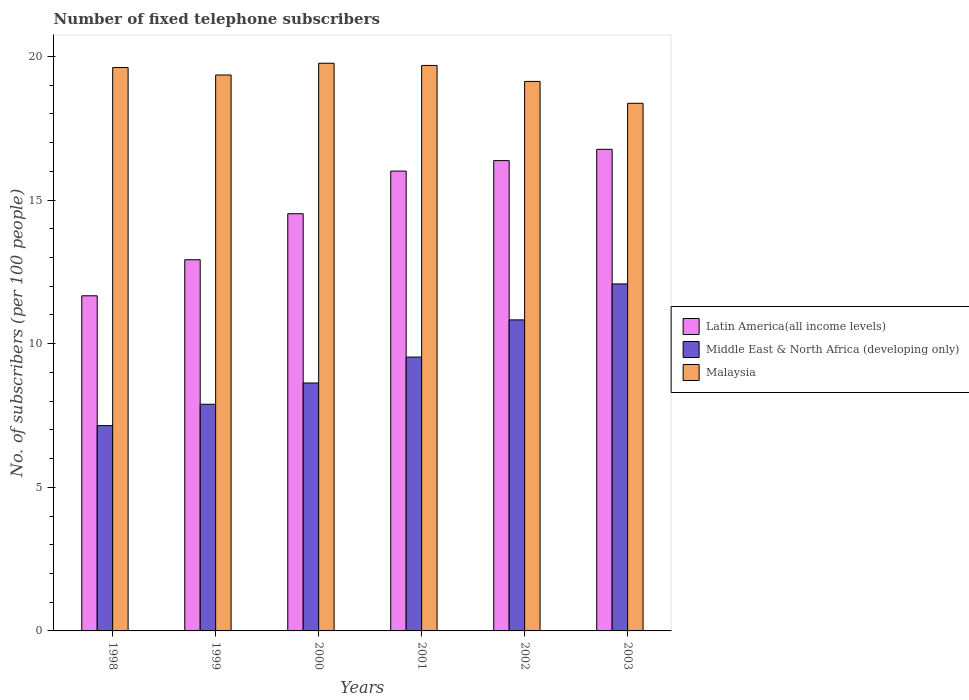How many different coloured bars are there?
Give a very brief answer. 3. How many groups of bars are there?
Your response must be concise. 6. What is the label of the 4th group of bars from the left?
Offer a very short reply. 2001. In how many cases, is the number of bars for a given year not equal to the number of legend labels?
Provide a succinct answer. 0. What is the number of fixed telephone subscribers in Malaysia in 1998?
Provide a short and direct response. 19.61. Across all years, what is the maximum number of fixed telephone subscribers in Latin America(all income levels)?
Ensure brevity in your answer.  16.76. Across all years, what is the minimum number of fixed telephone subscribers in Latin America(all income levels)?
Make the answer very short. 11.67. What is the total number of fixed telephone subscribers in Middle East & North Africa (developing only) in the graph?
Provide a short and direct response. 56.1. What is the difference between the number of fixed telephone subscribers in Malaysia in 2001 and that in 2002?
Offer a terse response. 0.56. What is the difference between the number of fixed telephone subscribers in Malaysia in 2000 and the number of fixed telephone subscribers in Latin America(all income levels) in 2002?
Provide a succinct answer. 3.39. What is the average number of fixed telephone subscribers in Latin America(all income levels) per year?
Your answer should be compact. 14.71. In the year 1998, what is the difference between the number of fixed telephone subscribers in Latin America(all income levels) and number of fixed telephone subscribers in Middle East & North Africa (developing only)?
Offer a terse response. 4.52. What is the ratio of the number of fixed telephone subscribers in Malaysia in 2002 to that in 2003?
Offer a terse response. 1.04. Is the number of fixed telephone subscribers in Malaysia in 1999 less than that in 2002?
Give a very brief answer. No. What is the difference between the highest and the second highest number of fixed telephone subscribers in Malaysia?
Offer a terse response. 0.08. What is the difference between the highest and the lowest number of fixed telephone subscribers in Latin America(all income levels)?
Give a very brief answer. 5.1. What does the 1st bar from the left in 2001 represents?
Make the answer very short. Latin America(all income levels). What does the 3rd bar from the right in 2000 represents?
Ensure brevity in your answer.  Latin America(all income levels). Is it the case that in every year, the sum of the number of fixed telephone subscribers in Latin America(all income levels) and number of fixed telephone subscribers in Middle East & North Africa (developing only) is greater than the number of fixed telephone subscribers in Malaysia?
Give a very brief answer. No. Are all the bars in the graph horizontal?
Give a very brief answer. No. How many years are there in the graph?
Your response must be concise. 6. Does the graph contain any zero values?
Offer a very short reply. No. Does the graph contain grids?
Give a very brief answer. No. Where does the legend appear in the graph?
Your answer should be very brief. Center right. How many legend labels are there?
Your response must be concise. 3. How are the legend labels stacked?
Your response must be concise. Vertical. What is the title of the graph?
Offer a very short reply. Number of fixed telephone subscribers. Does "Virgin Islands" appear as one of the legend labels in the graph?
Your answer should be very brief. No. What is the label or title of the Y-axis?
Provide a succinct answer. No. of subscribers (per 100 people). What is the No. of subscribers (per 100 people) of Latin America(all income levels) in 1998?
Provide a succinct answer. 11.67. What is the No. of subscribers (per 100 people) in Middle East & North Africa (developing only) in 1998?
Give a very brief answer. 7.15. What is the No. of subscribers (per 100 people) in Malaysia in 1998?
Keep it short and to the point. 19.61. What is the No. of subscribers (per 100 people) of Latin America(all income levels) in 1999?
Provide a short and direct response. 12.92. What is the No. of subscribers (per 100 people) in Middle East & North Africa (developing only) in 1999?
Give a very brief answer. 7.89. What is the No. of subscribers (per 100 people) of Malaysia in 1999?
Your response must be concise. 19.35. What is the No. of subscribers (per 100 people) in Latin America(all income levels) in 2000?
Your answer should be compact. 14.52. What is the No. of subscribers (per 100 people) in Middle East & North Africa (developing only) in 2000?
Provide a short and direct response. 8.63. What is the No. of subscribers (per 100 people) in Malaysia in 2000?
Your answer should be very brief. 19.76. What is the No. of subscribers (per 100 people) in Latin America(all income levels) in 2001?
Give a very brief answer. 16.01. What is the No. of subscribers (per 100 people) of Middle East & North Africa (developing only) in 2001?
Your answer should be compact. 9.53. What is the No. of subscribers (per 100 people) in Malaysia in 2001?
Make the answer very short. 19.68. What is the No. of subscribers (per 100 people) of Latin America(all income levels) in 2002?
Offer a terse response. 16.37. What is the No. of subscribers (per 100 people) of Middle East & North Africa (developing only) in 2002?
Keep it short and to the point. 10.83. What is the No. of subscribers (per 100 people) of Malaysia in 2002?
Offer a very short reply. 19.13. What is the No. of subscribers (per 100 people) in Latin America(all income levels) in 2003?
Give a very brief answer. 16.76. What is the No. of subscribers (per 100 people) of Middle East & North Africa (developing only) in 2003?
Offer a terse response. 12.08. What is the No. of subscribers (per 100 people) of Malaysia in 2003?
Offer a very short reply. 18.37. Across all years, what is the maximum No. of subscribers (per 100 people) in Latin America(all income levels)?
Give a very brief answer. 16.76. Across all years, what is the maximum No. of subscribers (per 100 people) of Middle East & North Africa (developing only)?
Offer a very short reply. 12.08. Across all years, what is the maximum No. of subscribers (per 100 people) of Malaysia?
Provide a succinct answer. 19.76. Across all years, what is the minimum No. of subscribers (per 100 people) of Latin America(all income levels)?
Offer a terse response. 11.67. Across all years, what is the minimum No. of subscribers (per 100 people) of Middle East & North Africa (developing only)?
Your response must be concise. 7.15. Across all years, what is the minimum No. of subscribers (per 100 people) in Malaysia?
Your answer should be very brief. 18.37. What is the total No. of subscribers (per 100 people) in Latin America(all income levels) in the graph?
Your response must be concise. 88.25. What is the total No. of subscribers (per 100 people) in Middle East & North Africa (developing only) in the graph?
Make the answer very short. 56.1. What is the total No. of subscribers (per 100 people) of Malaysia in the graph?
Offer a terse response. 115.9. What is the difference between the No. of subscribers (per 100 people) of Latin America(all income levels) in 1998 and that in 1999?
Offer a terse response. -1.25. What is the difference between the No. of subscribers (per 100 people) in Middle East & North Africa (developing only) in 1998 and that in 1999?
Provide a succinct answer. -0.74. What is the difference between the No. of subscribers (per 100 people) in Malaysia in 1998 and that in 1999?
Provide a succinct answer. 0.26. What is the difference between the No. of subscribers (per 100 people) of Latin America(all income levels) in 1998 and that in 2000?
Your answer should be very brief. -2.86. What is the difference between the No. of subscribers (per 100 people) of Middle East & North Africa (developing only) in 1998 and that in 2000?
Offer a terse response. -1.48. What is the difference between the No. of subscribers (per 100 people) in Malaysia in 1998 and that in 2000?
Offer a very short reply. -0.15. What is the difference between the No. of subscribers (per 100 people) in Latin America(all income levels) in 1998 and that in 2001?
Provide a short and direct response. -4.34. What is the difference between the No. of subscribers (per 100 people) of Middle East & North Africa (developing only) in 1998 and that in 2001?
Make the answer very short. -2.39. What is the difference between the No. of subscribers (per 100 people) in Malaysia in 1998 and that in 2001?
Give a very brief answer. -0.07. What is the difference between the No. of subscribers (per 100 people) in Latin America(all income levels) in 1998 and that in 2002?
Keep it short and to the point. -4.71. What is the difference between the No. of subscribers (per 100 people) in Middle East & North Africa (developing only) in 1998 and that in 2002?
Your answer should be compact. -3.68. What is the difference between the No. of subscribers (per 100 people) in Malaysia in 1998 and that in 2002?
Ensure brevity in your answer.  0.48. What is the difference between the No. of subscribers (per 100 people) of Latin America(all income levels) in 1998 and that in 2003?
Offer a terse response. -5.1. What is the difference between the No. of subscribers (per 100 people) in Middle East & North Africa (developing only) in 1998 and that in 2003?
Offer a terse response. -4.93. What is the difference between the No. of subscribers (per 100 people) of Malaysia in 1998 and that in 2003?
Make the answer very short. 1.24. What is the difference between the No. of subscribers (per 100 people) of Latin America(all income levels) in 1999 and that in 2000?
Offer a very short reply. -1.6. What is the difference between the No. of subscribers (per 100 people) of Middle East & North Africa (developing only) in 1999 and that in 2000?
Provide a succinct answer. -0.74. What is the difference between the No. of subscribers (per 100 people) of Malaysia in 1999 and that in 2000?
Give a very brief answer. -0.41. What is the difference between the No. of subscribers (per 100 people) of Latin America(all income levels) in 1999 and that in 2001?
Offer a very short reply. -3.09. What is the difference between the No. of subscribers (per 100 people) in Middle East & North Africa (developing only) in 1999 and that in 2001?
Provide a succinct answer. -1.64. What is the difference between the No. of subscribers (per 100 people) of Malaysia in 1999 and that in 2001?
Your answer should be very brief. -0.33. What is the difference between the No. of subscribers (per 100 people) of Latin America(all income levels) in 1999 and that in 2002?
Give a very brief answer. -3.45. What is the difference between the No. of subscribers (per 100 people) of Middle East & North Africa (developing only) in 1999 and that in 2002?
Your response must be concise. -2.94. What is the difference between the No. of subscribers (per 100 people) in Malaysia in 1999 and that in 2002?
Your response must be concise. 0.22. What is the difference between the No. of subscribers (per 100 people) in Latin America(all income levels) in 1999 and that in 2003?
Provide a short and direct response. -3.84. What is the difference between the No. of subscribers (per 100 people) of Middle East & North Africa (developing only) in 1999 and that in 2003?
Your answer should be compact. -4.19. What is the difference between the No. of subscribers (per 100 people) of Malaysia in 1999 and that in 2003?
Make the answer very short. 0.99. What is the difference between the No. of subscribers (per 100 people) of Latin America(all income levels) in 2000 and that in 2001?
Keep it short and to the point. -1.48. What is the difference between the No. of subscribers (per 100 people) of Middle East & North Africa (developing only) in 2000 and that in 2001?
Provide a succinct answer. -0.9. What is the difference between the No. of subscribers (per 100 people) in Malaysia in 2000 and that in 2001?
Offer a very short reply. 0.08. What is the difference between the No. of subscribers (per 100 people) of Latin America(all income levels) in 2000 and that in 2002?
Provide a succinct answer. -1.85. What is the difference between the No. of subscribers (per 100 people) in Middle East & North Africa (developing only) in 2000 and that in 2002?
Provide a short and direct response. -2.2. What is the difference between the No. of subscribers (per 100 people) in Malaysia in 2000 and that in 2002?
Your response must be concise. 0.63. What is the difference between the No. of subscribers (per 100 people) in Latin America(all income levels) in 2000 and that in 2003?
Give a very brief answer. -2.24. What is the difference between the No. of subscribers (per 100 people) in Middle East & North Africa (developing only) in 2000 and that in 2003?
Make the answer very short. -3.45. What is the difference between the No. of subscribers (per 100 people) in Malaysia in 2000 and that in 2003?
Provide a short and direct response. 1.39. What is the difference between the No. of subscribers (per 100 people) of Latin America(all income levels) in 2001 and that in 2002?
Keep it short and to the point. -0.37. What is the difference between the No. of subscribers (per 100 people) of Middle East & North Africa (developing only) in 2001 and that in 2002?
Offer a terse response. -1.29. What is the difference between the No. of subscribers (per 100 people) of Malaysia in 2001 and that in 2002?
Your response must be concise. 0.56. What is the difference between the No. of subscribers (per 100 people) of Latin America(all income levels) in 2001 and that in 2003?
Give a very brief answer. -0.76. What is the difference between the No. of subscribers (per 100 people) of Middle East & North Africa (developing only) in 2001 and that in 2003?
Your answer should be very brief. -2.55. What is the difference between the No. of subscribers (per 100 people) in Malaysia in 2001 and that in 2003?
Your response must be concise. 1.32. What is the difference between the No. of subscribers (per 100 people) in Latin America(all income levels) in 2002 and that in 2003?
Ensure brevity in your answer.  -0.39. What is the difference between the No. of subscribers (per 100 people) of Middle East & North Africa (developing only) in 2002 and that in 2003?
Your answer should be very brief. -1.25. What is the difference between the No. of subscribers (per 100 people) in Malaysia in 2002 and that in 2003?
Offer a terse response. 0.76. What is the difference between the No. of subscribers (per 100 people) of Latin America(all income levels) in 1998 and the No. of subscribers (per 100 people) of Middle East & North Africa (developing only) in 1999?
Keep it short and to the point. 3.78. What is the difference between the No. of subscribers (per 100 people) in Latin America(all income levels) in 1998 and the No. of subscribers (per 100 people) in Malaysia in 1999?
Make the answer very short. -7.69. What is the difference between the No. of subscribers (per 100 people) of Middle East & North Africa (developing only) in 1998 and the No. of subscribers (per 100 people) of Malaysia in 1999?
Your response must be concise. -12.21. What is the difference between the No. of subscribers (per 100 people) in Latin America(all income levels) in 1998 and the No. of subscribers (per 100 people) in Middle East & North Africa (developing only) in 2000?
Provide a succinct answer. 3.04. What is the difference between the No. of subscribers (per 100 people) in Latin America(all income levels) in 1998 and the No. of subscribers (per 100 people) in Malaysia in 2000?
Offer a very short reply. -8.09. What is the difference between the No. of subscribers (per 100 people) in Middle East & North Africa (developing only) in 1998 and the No. of subscribers (per 100 people) in Malaysia in 2000?
Your answer should be very brief. -12.61. What is the difference between the No. of subscribers (per 100 people) of Latin America(all income levels) in 1998 and the No. of subscribers (per 100 people) of Middle East & North Africa (developing only) in 2001?
Offer a very short reply. 2.13. What is the difference between the No. of subscribers (per 100 people) of Latin America(all income levels) in 1998 and the No. of subscribers (per 100 people) of Malaysia in 2001?
Provide a short and direct response. -8.02. What is the difference between the No. of subscribers (per 100 people) of Middle East & North Africa (developing only) in 1998 and the No. of subscribers (per 100 people) of Malaysia in 2001?
Make the answer very short. -12.54. What is the difference between the No. of subscribers (per 100 people) of Latin America(all income levels) in 1998 and the No. of subscribers (per 100 people) of Middle East & North Africa (developing only) in 2002?
Give a very brief answer. 0.84. What is the difference between the No. of subscribers (per 100 people) of Latin America(all income levels) in 1998 and the No. of subscribers (per 100 people) of Malaysia in 2002?
Make the answer very short. -7.46. What is the difference between the No. of subscribers (per 100 people) in Middle East & North Africa (developing only) in 1998 and the No. of subscribers (per 100 people) in Malaysia in 2002?
Provide a short and direct response. -11.98. What is the difference between the No. of subscribers (per 100 people) in Latin America(all income levels) in 1998 and the No. of subscribers (per 100 people) in Middle East & North Africa (developing only) in 2003?
Ensure brevity in your answer.  -0.41. What is the difference between the No. of subscribers (per 100 people) of Latin America(all income levels) in 1998 and the No. of subscribers (per 100 people) of Malaysia in 2003?
Keep it short and to the point. -6.7. What is the difference between the No. of subscribers (per 100 people) in Middle East & North Africa (developing only) in 1998 and the No. of subscribers (per 100 people) in Malaysia in 2003?
Offer a terse response. -11.22. What is the difference between the No. of subscribers (per 100 people) in Latin America(all income levels) in 1999 and the No. of subscribers (per 100 people) in Middle East & North Africa (developing only) in 2000?
Ensure brevity in your answer.  4.29. What is the difference between the No. of subscribers (per 100 people) in Latin America(all income levels) in 1999 and the No. of subscribers (per 100 people) in Malaysia in 2000?
Offer a very short reply. -6.84. What is the difference between the No. of subscribers (per 100 people) of Middle East & North Africa (developing only) in 1999 and the No. of subscribers (per 100 people) of Malaysia in 2000?
Offer a terse response. -11.87. What is the difference between the No. of subscribers (per 100 people) in Latin America(all income levels) in 1999 and the No. of subscribers (per 100 people) in Middle East & North Africa (developing only) in 2001?
Your answer should be very brief. 3.39. What is the difference between the No. of subscribers (per 100 people) in Latin America(all income levels) in 1999 and the No. of subscribers (per 100 people) in Malaysia in 2001?
Give a very brief answer. -6.76. What is the difference between the No. of subscribers (per 100 people) of Middle East & North Africa (developing only) in 1999 and the No. of subscribers (per 100 people) of Malaysia in 2001?
Make the answer very short. -11.79. What is the difference between the No. of subscribers (per 100 people) in Latin America(all income levels) in 1999 and the No. of subscribers (per 100 people) in Middle East & North Africa (developing only) in 2002?
Your answer should be compact. 2.09. What is the difference between the No. of subscribers (per 100 people) of Latin America(all income levels) in 1999 and the No. of subscribers (per 100 people) of Malaysia in 2002?
Keep it short and to the point. -6.21. What is the difference between the No. of subscribers (per 100 people) of Middle East & North Africa (developing only) in 1999 and the No. of subscribers (per 100 people) of Malaysia in 2002?
Provide a succinct answer. -11.24. What is the difference between the No. of subscribers (per 100 people) in Latin America(all income levels) in 1999 and the No. of subscribers (per 100 people) in Middle East & North Africa (developing only) in 2003?
Give a very brief answer. 0.84. What is the difference between the No. of subscribers (per 100 people) of Latin America(all income levels) in 1999 and the No. of subscribers (per 100 people) of Malaysia in 2003?
Make the answer very short. -5.45. What is the difference between the No. of subscribers (per 100 people) of Middle East & North Africa (developing only) in 1999 and the No. of subscribers (per 100 people) of Malaysia in 2003?
Provide a succinct answer. -10.48. What is the difference between the No. of subscribers (per 100 people) of Latin America(all income levels) in 2000 and the No. of subscribers (per 100 people) of Middle East & North Africa (developing only) in 2001?
Keep it short and to the point. 4.99. What is the difference between the No. of subscribers (per 100 people) in Latin America(all income levels) in 2000 and the No. of subscribers (per 100 people) in Malaysia in 2001?
Offer a terse response. -5.16. What is the difference between the No. of subscribers (per 100 people) of Middle East & North Africa (developing only) in 2000 and the No. of subscribers (per 100 people) of Malaysia in 2001?
Offer a terse response. -11.05. What is the difference between the No. of subscribers (per 100 people) of Latin America(all income levels) in 2000 and the No. of subscribers (per 100 people) of Middle East & North Africa (developing only) in 2002?
Keep it short and to the point. 3.7. What is the difference between the No. of subscribers (per 100 people) of Latin America(all income levels) in 2000 and the No. of subscribers (per 100 people) of Malaysia in 2002?
Ensure brevity in your answer.  -4.61. What is the difference between the No. of subscribers (per 100 people) of Middle East & North Africa (developing only) in 2000 and the No. of subscribers (per 100 people) of Malaysia in 2002?
Offer a terse response. -10.5. What is the difference between the No. of subscribers (per 100 people) of Latin America(all income levels) in 2000 and the No. of subscribers (per 100 people) of Middle East & North Africa (developing only) in 2003?
Your answer should be compact. 2.44. What is the difference between the No. of subscribers (per 100 people) in Latin America(all income levels) in 2000 and the No. of subscribers (per 100 people) in Malaysia in 2003?
Give a very brief answer. -3.84. What is the difference between the No. of subscribers (per 100 people) of Middle East & North Africa (developing only) in 2000 and the No. of subscribers (per 100 people) of Malaysia in 2003?
Give a very brief answer. -9.74. What is the difference between the No. of subscribers (per 100 people) in Latin America(all income levels) in 2001 and the No. of subscribers (per 100 people) in Middle East & North Africa (developing only) in 2002?
Provide a short and direct response. 5.18. What is the difference between the No. of subscribers (per 100 people) in Latin America(all income levels) in 2001 and the No. of subscribers (per 100 people) in Malaysia in 2002?
Provide a succinct answer. -3.12. What is the difference between the No. of subscribers (per 100 people) in Middle East & North Africa (developing only) in 2001 and the No. of subscribers (per 100 people) in Malaysia in 2002?
Your answer should be compact. -9.6. What is the difference between the No. of subscribers (per 100 people) of Latin America(all income levels) in 2001 and the No. of subscribers (per 100 people) of Middle East & North Africa (developing only) in 2003?
Give a very brief answer. 3.93. What is the difference between the No. of subscribers (per 100 people) in Latin America(all income levels) in 2001 and the No. of subscribers (per 100 people) in Malaysia in 2003?
Your response must be concise. -2.36. What is the difference between the No. of subscribers (per 100 people) of Middle East & North Africa (developing only) in 2001 and the No. of subscribers (per 100 people) of Malaysia in 2003?
Provide a succinct answer. -8.83. What is the difference between the No. of subscribers (per 100 people) of Latin America(all income levels) in 2002 and the No. of subscribers (per 100 people) of Middle East & North Africa (developing only) in 2003?
Offer a terse response. 4.29. What is the difference between the No. of subscribers (per 100 people) of Latin America(all income levels) in 2002 and the No. of subscribers (per 100 people) of Malaysia in 2003?
Provide a short and direct response. -1.99. What is the difference between the No. of subscribers (per 100 people) in Middle East & North Africa (developing only) in 2002 and the No. of subscribers (per 100 people) in Malaysia in 2003?
Give a very brief answer. -7.54. What is the average No. of subscribers (per 100 people) in Latin America(all income levels) per year?
Make the answer very short. 14.71. What is the average No. of subscribers (per 100 people) in Middle East & North Africa (developing only) per year?
Your answer should be very brief. 9.35. What is the average No. of subscribers (per 100 people) of Malaysia per year?
Offer a very short reply. 19.32. In the year 1998, what is the difference between the No. of subscribers (per 100 people) in Latin America(all income levels) and No. of subscribers (per 100 people) in Middle East & North Africa (developing only)?
Your answer should be compact. 4.52. In the year 1998, what is the difference between the No. of subscribers (per 100 people) in Latin America(all income levels) and No. of subscribers (per 100 people) in Malaysia?
Give a very brief answer. -7.95. In the year 1998, what is the difference between the No. of subscribers (per 100 people) of Middle East & North Africa (developing only) and No. of subscribers (per 100 people) of Malaysia?
Give a very brief answer. -12.47. In the year 1999, what is the difference between the No. of subscribers (per 100 people) in Latin America(all income levels) and No. of subscribers (per 100 people) in Middle East & North Africa (developing only)?
Make the answer very short. 5.03. In the year 1999, what is the difference between the No. of subscribers (per 100 people) of Latin America(all income levels) and No. of subscribers (per 100 people) of Malaysia?
Your answer should be compact. -6.43. In the year 1999, what is the difference between the No. of subscribers (per 100 people) in Middle East & North Africa (developing only) and No. of subscribers (per 100 people) in Malaysia?
Your answer should be compact. -11.46. In the year 2000, what is the difference between the No. of subscribers (per 100 people) in Latin America(all income levels) and No. of subscribers (per 100 people) in Middle East & North Africa (developing only)?
Give a very brief answer. 5.89. In the year 2000, what is the difference between the No. of subscribers (per 100 people) of Latin America(all income levels) and No. of subscribers (per 100 people) of Malaysia?
Provide a short and direct response. -5.24. In the year 2000, what is the difference between the No. of subscribers (per 100 people) of Middle East & North Africa (developing only) and No. of subscribers (per 100 people) of Malaysia?
Give a very brief answer. -11.13. In the year 2001, what is the difference between the No. of subscribers (per 100 people) in Latin America(all income levels) and No. of subscribers (per 100 people) in Middle East & North Africa (developing only)?
Offer a very short reply. 6.47. In the year 2001, what is the difference between the No. of subscribers (per 100 people) in Latin America(all income levels) and No. of subscribers (per 100 people) in Malaysia?
Keep it short and to the point. -3.68. In the year 2001, what is the difference between the No. of subscribers (per 100 people) in Middle East & North Africa (developing only) and No. of subscribers (per 100 people) in Malaysia?
Offer a terse response. -10.15. In the year 2002, what is the difference between the No. of subscribers (per 100 people) of Latin America(all income levels) and No. of subscribers (per 100 people) of Middle East & North Africa (developing only)?
Your response must be concise. 5.54. In the year 2002, what is the difference between the No. of subscribers (per 100 people) in Latin America(all income levels) and No. of subscribers (per 100 people) in Malaysia?
Provide a short and direct response. -2.76. In the year 2002, what is the difference between the No. of subscribers (per 100 people) of Middle East & North Africa (developing only) and No. of subscribers (per 100 people) of Malaysia?
Provide a short and direct response. -8.3. In the year 2003, what is the difference between the No. of subscribers (per 100 people) of Latin America(all income levels) and No. of subscribers (per 100 people) of Middle East & North Africa (developing only)?
Offer a terse response. 4.69. In the year 2003, what is the difference between the No. of subscribers (per 100 people) of Latin America(all income levels) and No. of subscribers (per 100 people) of Malaysia?
Ensure brevity in your answer.  -1.6. In the year 2003, what is the difference between the No. of subscribers (per 100 people) in Middle East & North Africa (developing only) and No. of subscribers (per 100 people) in Malaysia?
Offer a terse response. -6.29. What is the ratio of the No. of subscribers (per 100 people) of Latin America(all income levels) in 1998 to that in 1999?
Ensure brevity in your answer.  0.9. What is the ratio of the No. of subscribers (per 100 people) in Middle East & North Africa (developing only) in 1998 to that in 1999?
Provide a short and direct response. 0.91. What is the ratio of the No. of subscribers (per 100 people) in Malaysia in 1998 to that in 1999?
Make the answer very short. 1.01. What is the ratio of the No. of subscribers (per 100 people) of Latin America(all income levels) in 1998 to that in 2000?
Keep it short and to the point. 0.8. What is the ratio of the No. of subscribers (per 100 people) of Middle East & North Africa (developing only) in 1998 to that in 2000?
Offer a terse response. 0.83. What is the ratio of the No. of subscribers (per 100 people) in Latin America(all income levels) in 1998 to that in 2001?
Offer a terse response. 0.73. What is the ratio of the No. of subscribers (per 100 people) of Middle East & North Africa (developing only) in 1998 to that in 2001?
Give a very brief answer. 0.75. What is the ratio of the No. of subscribers (per 100 people) in Malaysia in 1998 to that in 2001?
Make the answer very short. 1. What is the ratio of the No. of subscribers (per 100 people) in Latin America(all income levels) in 1998 to that in 2002?
Your answer should be compact. 0.71. What is the ratio of the No. of subscribers (per 100 people) in Middle East & North Africa (developing only) in 1998 to that in 2002?
Your answer should be very brief. 0.66. What is the ratio of the No. of subscribers (per 100 people) of Malaysia in 1998 to that in 2002?
Offer a very short reply. 1.03. What is the ratio of the No. of subscribers (per 100 people) of Latin America(all income levels) in 1998 to that in 2003?
Provide a short and direct response. 0.7. What is the ratio of the No. of subscribers (per 100 people) in Middle East & North Africa (developing only) in 1998 to that in 2003?
Keep it short and to the point. 0.59. What is the ratio of the No. of subscribers (per 100 people) in Malaysia in 1998 to that in 2003?
Your answer should be compact. 1.07. What is the ratio of the No. of subscribers (per 100 people) of Latin America(all income levels) in 1999 to that in 2000?
Make the answer very short. 0.89. What is the ratio of the No. of subscribers (per 100 people) of Middle East & North Africa (developing only) in 1999 to that in 2000?
Offer a terse response. 0.91. What is the ratio of the No. of subscribers (per 100 people) in Malaysia in 1999 to that in 2000?
Provide a short and direct response. 0.98. What is the ratio of the No. of subscribers (per 100 people) in Latin America(all income levels) in 1999 to that in 2001?
Offer a very short reply. 0.81. What is the ratio of the No. of subscribers (per 100 people) in Middle East & North Africa (developing only) in 1999 to that in 2001?
Your answer should be compact. 0.83. What is the ratio of the No. of subscribers (per 100 people) in Malaysia in 1999 to that in 2001?
Make the answer very short. 0.98. What is the ratio of the No. of subscribers (per 100 people) in Latin America(all income levels) in 1999 to that in 2002?
Your response must be concise. 0.79. What is the ratio of the No. of subscribers (per 100 people) of Middle East & North Africa (developing only) in 1999 to that in 2002?
Offer a terse response. 0.73. What is the ratio of the No. of subscribers (per 100 people) of Malaysia in 1999 to that in 2002?
Provide a short and direct response. 1.01. What is the ratio of the No. of subscribers (per 100 people) in Latin America(all income levels) in 1999 to that in 2003?
Your answer should be very brief. 0.77. What is the ratio of the No. of subscribers (per 100 people) in Middle East & North Africa (developing only) in 1999 to that in 2003?
Provide a short and direct response. 0.65. What is the ratio of the No. of subscribers (per 100 people) in Malaysia in 1999 to that in 2003?
Ensure brevity in your answer.  1.05. What is the ratio of the No. of subscribers (per 100 people) in Latin America(all income levels) in 2000 to that in 2001?
Your answer should be compact. 0.91. What is the ratio of the No. of subscribers (per 100 people) in Middle East & North Africa (developing only) in 2000 to that in 2001?
Provide a short and direct response. 0.91. What is the ratio of the No. of subscribers (per 100 people) in Latin America(all income levels) in 2000 to that in 2002?
Give a very brief answer. 0.89. What is the ratio of the No. of subscribers (per 100 people) of Middle East & North Africa (developing only) in 2000 to that in 2002?
Provide a succinct answer. 0.8. What is the ratio of the No. of subscribers (per 100 people) in Malaysia in 2000 to that in 2002?
Your response must be concise. 1.03. What is the ratio of the No. of subscribers (per 100 people) in Latin America(all income levels) in 2000 to that in 2003?
Offer a terse response. 0.87. What is the ratio of the No. of subscribers (per 100 people) in Middle East & North Africa (developing only) in 2000 to that in 2003?
Provide a succinct answer. 0.71. What is the ratio of the No. of subscribers (per 100 people) of Malaysia in 2000 to that in 2003?
Give a very brief answer. 1.08. What is the ratio of the No. of subscribers (per 100 people) of Latin America(all income levels) in 2001 to that in 2002?
Your answer should be very brief. 0.98. What is the ratio of the No. of subscribers (per 100 people) in Middle East & North Africa (developing only) in 2001 to that in 2002?
Your answer should be very brief. 0.88. What is the ratio of the No. of subscribers (per 100 people) of Malaysia in 2001 to that in 2002?
Your response must be concise. 1.03. What is the ratio of the No. of subscribers (per 100 people) in Latin America(all income levels) in 2001 to that in 2003?
Offer a very short reply. 0.95. What is the ratio of the No. of subscribers (per 100 people) of Middle East & North Africa (developing only) in 2001 to that in 2003?
Keep it short and to the point. 0.79. What is the ratio of the No. of subscribers (per 100 people) in Malaysia in 2001 to that in 2003?
Provide a succinct answer. 1.07. What is the ratio of the No. of subscribers (per 100 people) of Latin America(all income levels) in 2002 to that in 2003?
Provide a short and direct response. 0.98. What is the ratio of the No. of subscribers (per 100 people) in Middle East & North Africa (developing only) in 2002 to that in 2003?
Your answer should be compact. 0.9. What is the ratio of the No. of subscribers (per 100 people) in Malaysia in 2002 to that in 2003?
Provide a succinct answer. 1.04. What is the difference between the highest and the second highest No. of subscribers (per 100 people) of Latin America(all income levels)?
Your answer should be compact. 0.39. What is the difference between the highest and the second highest No. of subscribers (per 100 people) in Middle East & North Africa (developing only)?
Keep it short and to the point. 1.25. What is the difference between the highest and the second highest No. of subscribers (per 100 people) of Malaysia?
Your answer should be compact. 0.08. What is the difference between the highest and the lowest No. of subscribers (per 100 people) of Latin America(all income levels)?
Make the answer very short. 5.1. What is the difference between the highest and the lowest No. of subscribers (per 100 people) in Middle East & North Africa (developing only)?
Provide a succinct answer. 4.93. What is the difference between the highest and the lowest No. of subscribers (per 100 people) of Malaysia?
Offer a terse response. 1.39. 